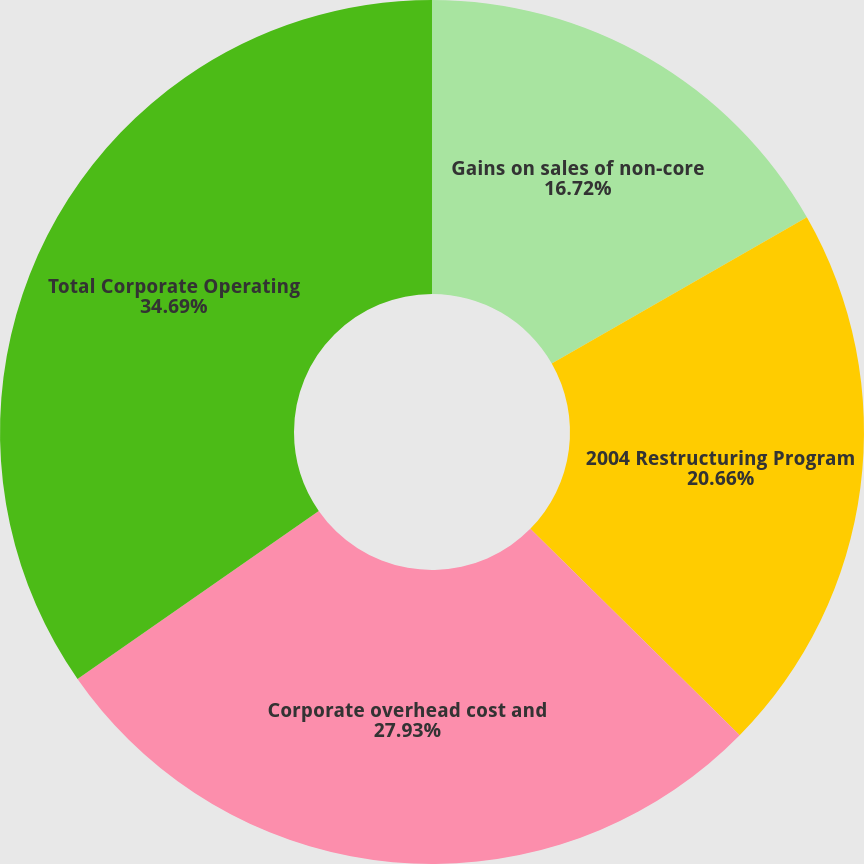Convert chart to OTSL. <chart><loc_0><loc_0><loc_500><loc_500><pie_chart><fcel>Gains on sales of non-core<fcel>2004 Restructuring Program<fcel>Corporate overhead cost and<fcel>Total Corporate Operating<nl><fcel>16.72%<fcel>20.66%<fcel>27.93%<fcel>34.68%<nl></chart> 